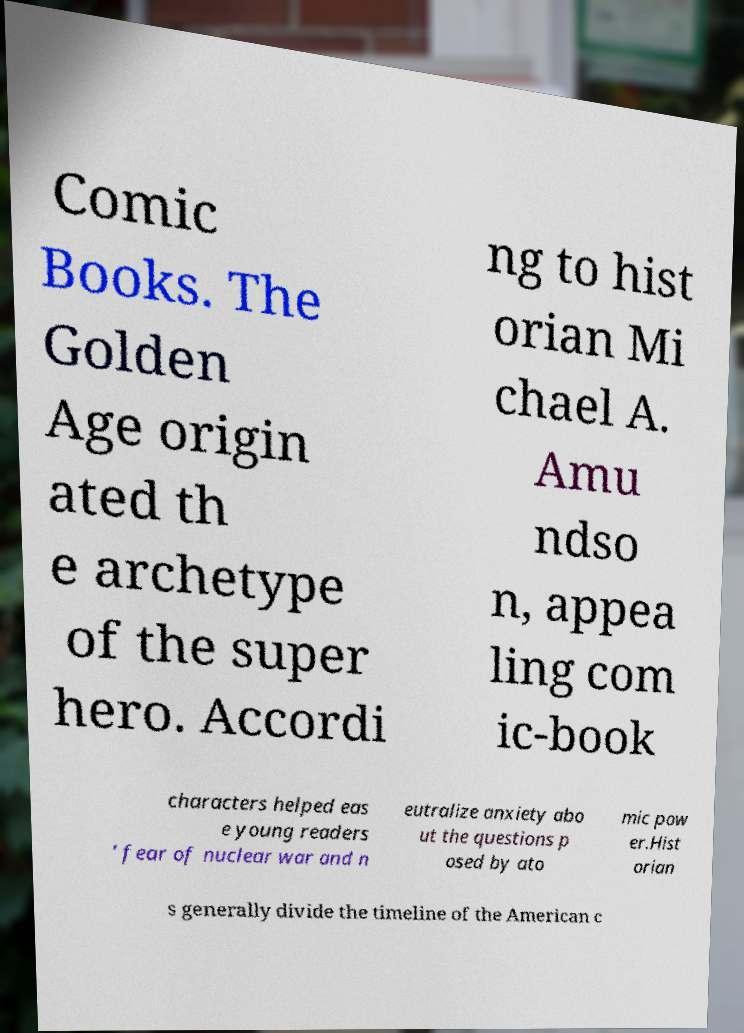There's text embedded in this image that I need extracted. Can you transcribe it verbatim? Comic Books. The Golden Age origin ated th e archetype of the super hero. Accordi ng to hist orian Mi chael A. Amu ndso n, appea ling com ic-book characters helped eas e young readers ' fear of nuclear war and n eutralize anxiety abo ut the questions p osed by ato mic pow er.Hist orian s generally divide the timeline of the American c 